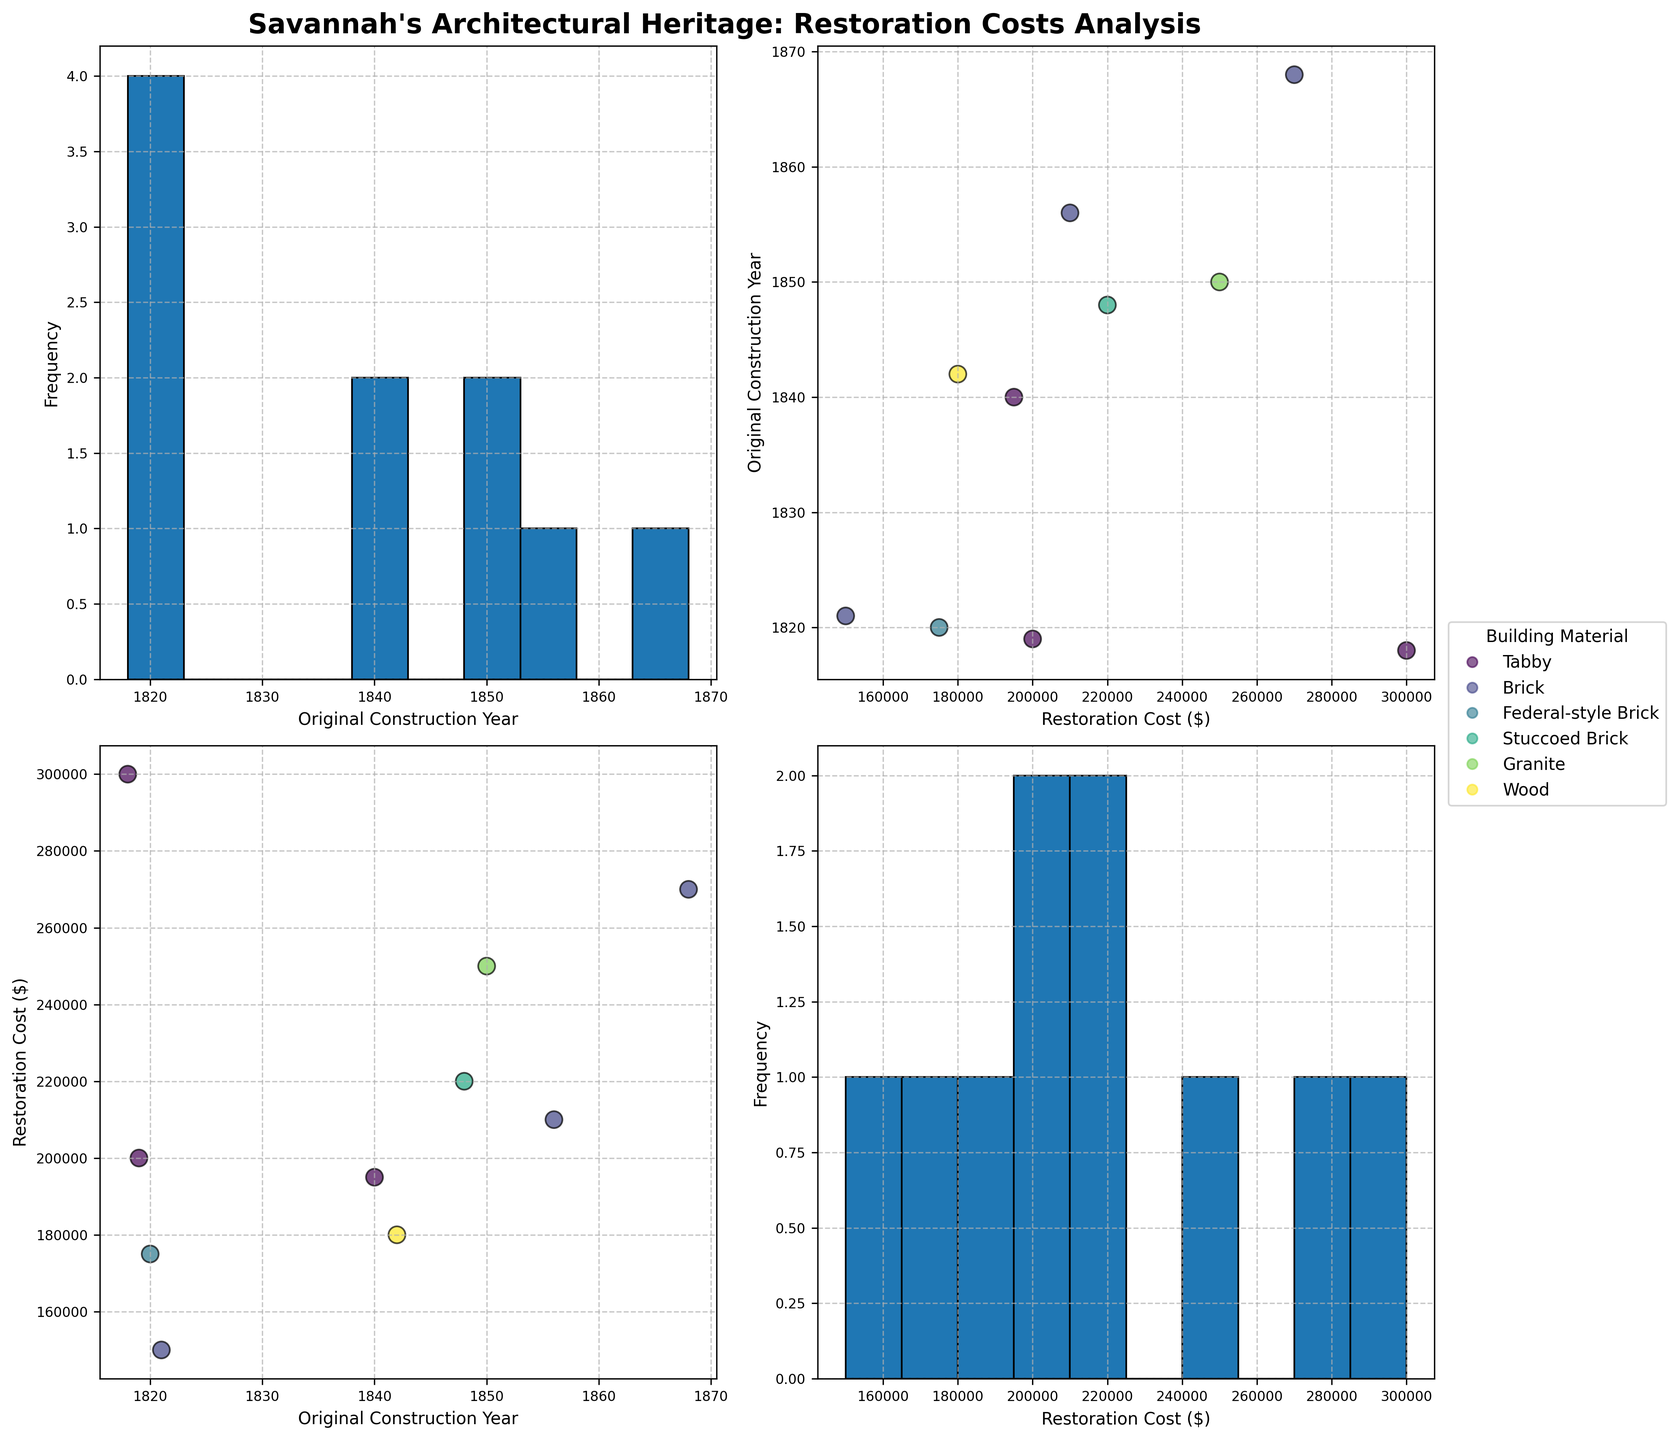What's the title of the figure? The title is generally located at the top of the figure and provides a summary of the content. In this case, “Savannah's Architectural Heritage: Restoration Costs Analysis” is written at the top in bold letters.
Answer: Savannah's Architectural Heritage: Restoration Costs Analysis How many buildings use Tabby as the building material type? To answer this, observe the legend on the right side of the figure which lists different building material types. Then, refer to the scatter plots to count the data points colored according to the Tabby category.
Answer: 3 What is the range of the 'Restoration Cost ($)'? The histogram on the diagonal that plots 'Restoration Cost ($)' on both axes will show the range as the x-axis values range from the lowest to highest amounts.
Answer: $150,000 to $300,000 Do buildings made of Brick tend to have higher restoration costs compared to buildings made of Tabby? First, look at the scatter plots and locate data points for Brick and Tabby, using colors indicated by the legend. Then observe and compare their positions along the 'Restoration Cost ($)' axis.
Answer: Yes Which building material has the widest spread in restoration costs? By examining scatter plots and observing how spread out the data points are across the 'Restoration Cost ($)' axis for each building material type, you can determine which material exhibits the widest spread.
Answer: Brick Are there more buildings constructed before 1850 or after? Refer to the histogram plotting 'Original Construction Year' on both axes. Observe the frequency of buildings constructed before 1850 and those after. Compare the heights of the bars in the relevant ranges.
Answer: Before Is there a trend between 'Original Construction Year' and 'Restoration Cost ($)'? Examine the scatter plot where 'Original Construction Year' is on one axis and 'Restoration Cost ($)' on the other. Look for any noticeable trend or pattern in the distribution of data points.
Answer: No clear trend Which building has the highest restoration cost, and what is its construction year? Find the scatter plot for 'Restoration Cost ($)' against 'Original Construction Year'. Locate the highest point on the 'Restoration Cost ($)' axis and trace it horizontally to identify the building and its construction year.
Answer: The Telfair Academy of Arts and Sciences, 1818 What's the average restoration cost for buildings constructed in the 1840s? Look at the scatter plot and histogram data to identify buildings constructed in the 1840s. Sum the restoration costs of these buildings and divide by the number of buildings.
Answer: $198,750 What's the most common building material type used in the dataset? Refer to the legend and then observe the scatter plots to count the frequency of each building material type by their color designation.
Answer: Brick 